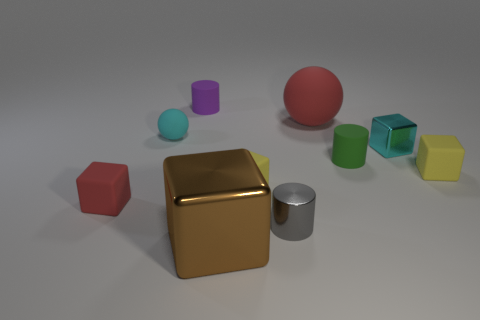Subtract all small metal blocks. How many blocks are left? 4 Subtract all large red rubber spheres. Subtract all tiny gray metal objects. How many objects are left? 8 Add 2 red blocks. How many red blocks are left? 3 Add 6 big purple rubber cylinders. How many big purple rubber cylinders exist? 6 Subtract all gray cylinders. How many cylinders are left? 2 Subtract 0 purple balls. How many objects are left? 10 Subtract all cylinders. How many objects are left? 7 Subtract 1 spheres. How many spheres are left? 1 Subtract all blue balls. Subtract all brown cylinders. How many balls are left? 2 Subtract all green spheres. How many blue blocks are left? 0 